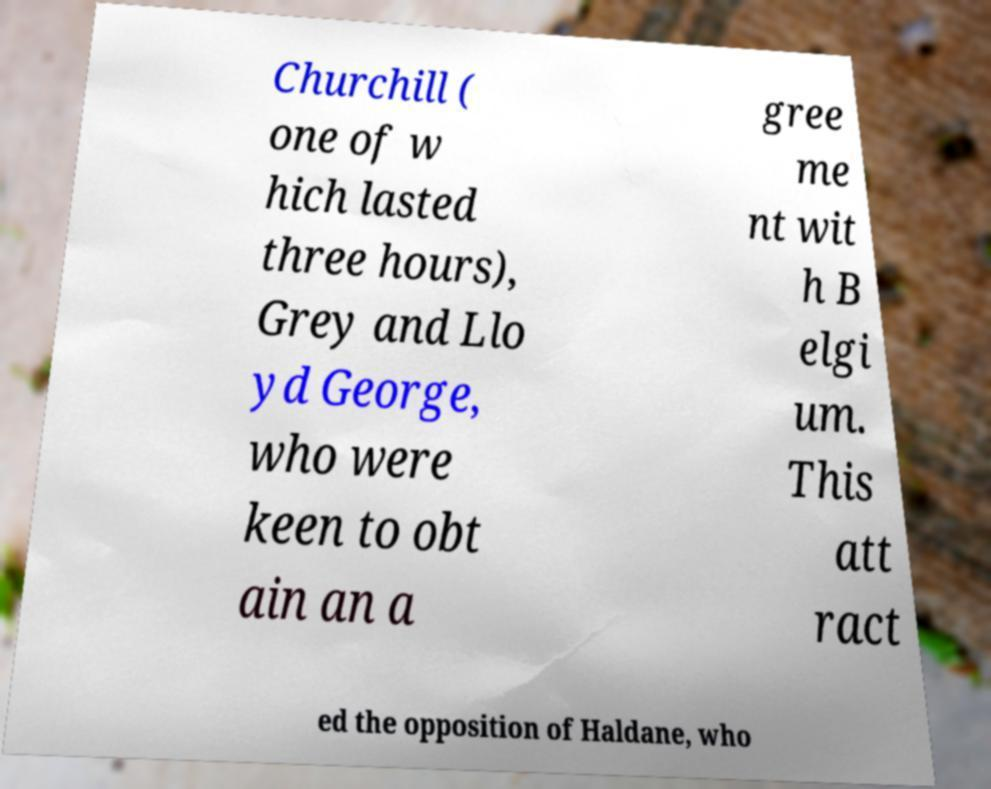I need the written content from this picture converted into text. Can you do that? Churchill ( one of w hich lasted three hours), Grey and Llo yd George, who were keen to obt ain an a gree me nt wit h B elgi um. This att ract ed the opposition of Haldane, who 